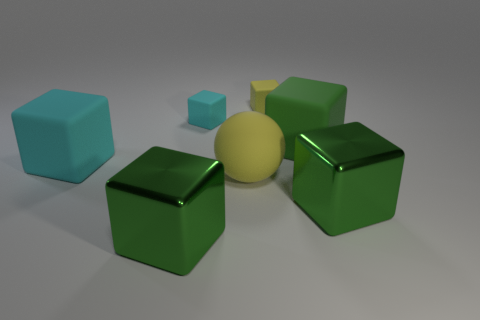Subtract all red balls. How many green blocks are left? 3 Subtract 1 blocks. How many blocks are left? 5 Subtract all tiny cyan cubes. How many cubes are left? 5 Subtract all yellow blocks. How many blocks are left? 5 Subtract all yellow cubes. Subtract all gray balls. How many cubes are left? 5 Add 3 balls. How many objects exist? 10 Subtract all cubes. How many objects are left? 1 Add 6 big spheres. How many big spheres are left? 7 Add 7 small objects. How many small objects exist? 9 Subtract 0 brown balls. How many objects are left? 7 